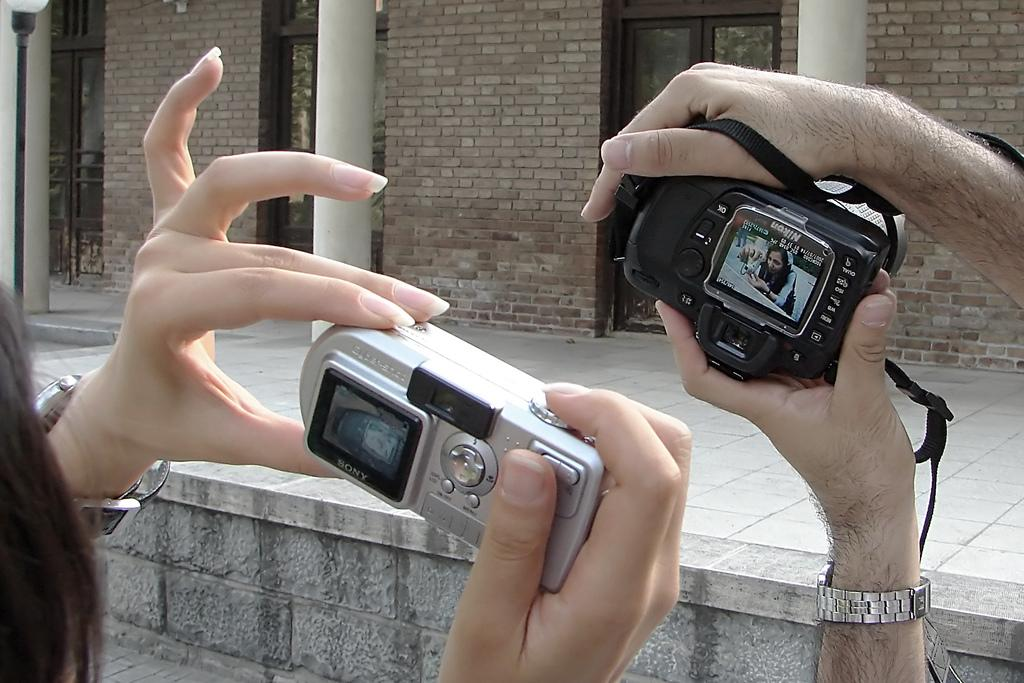How many people are in the image? There are two persons in the image. What are the persons holding? Both persons are holding cameras. What type of building is in the image? There is a house in the image. How many doors does the house have? The house has three doors. What object provides light in the image? There is a lamp in the image. What type of care can be seen being provided to the rail in the image? There is no rail present in the image, so care cannot be provided to it. 